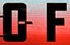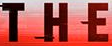What text is displayed in these images sequentially, separated by a semicolon? OF; THE 